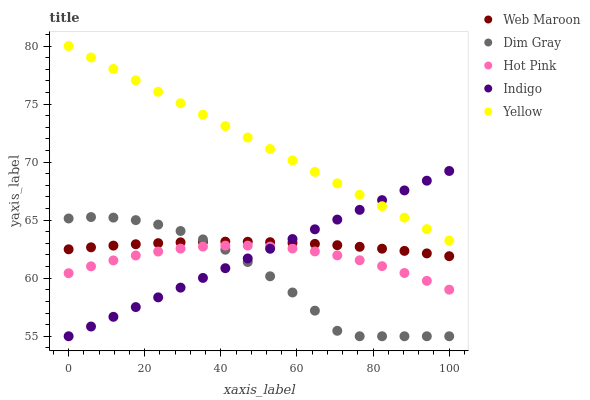Does Dim Gray have the minimum area under the curve?
Answer yes or no. Yes. Does Yellow have the maximum area under the curve?
Answer yes or no. Yes. Does Web Maroon have the minimum area under the curve?
Answer yes or no. No. Does Web Maroon have the maximum area under the curve?
Answer yes or no. No. Is Indigo the smoothest?
Answer yes or no. Yes. Is Dim Gray the roughest?
Answer yes or no. Yes. Is Web Maroon the smoothest?
Answer yes or no. No. Is Web Maroon the roughest?
Answer yes or no. No. Does Indigo have the lowest value?
Answer yes or no. Yes. Does Web Maroon have the lowest value?
Answer yes or no. No. Does Yellow have the highest value?
Answer yes or no. Yes. Does Dim Gray have the highest value?
Answer yes or no. No. Is Hot Pink less than Web Maroon?
Answer yes or no. Yes. Is Yellow greater than Dim Gray?
Answer yes or no. Yes. Does Hot Pink intersect Indigo?
Answer yes or no. Yes. Is Hot Pink less than Indigo?
Answer yes or no. No. Is Hot Pink greater than Indigo?
Answer yes or no. No. Does Hot Pink intersect Web Maroon?
Answer yes or no. No. 